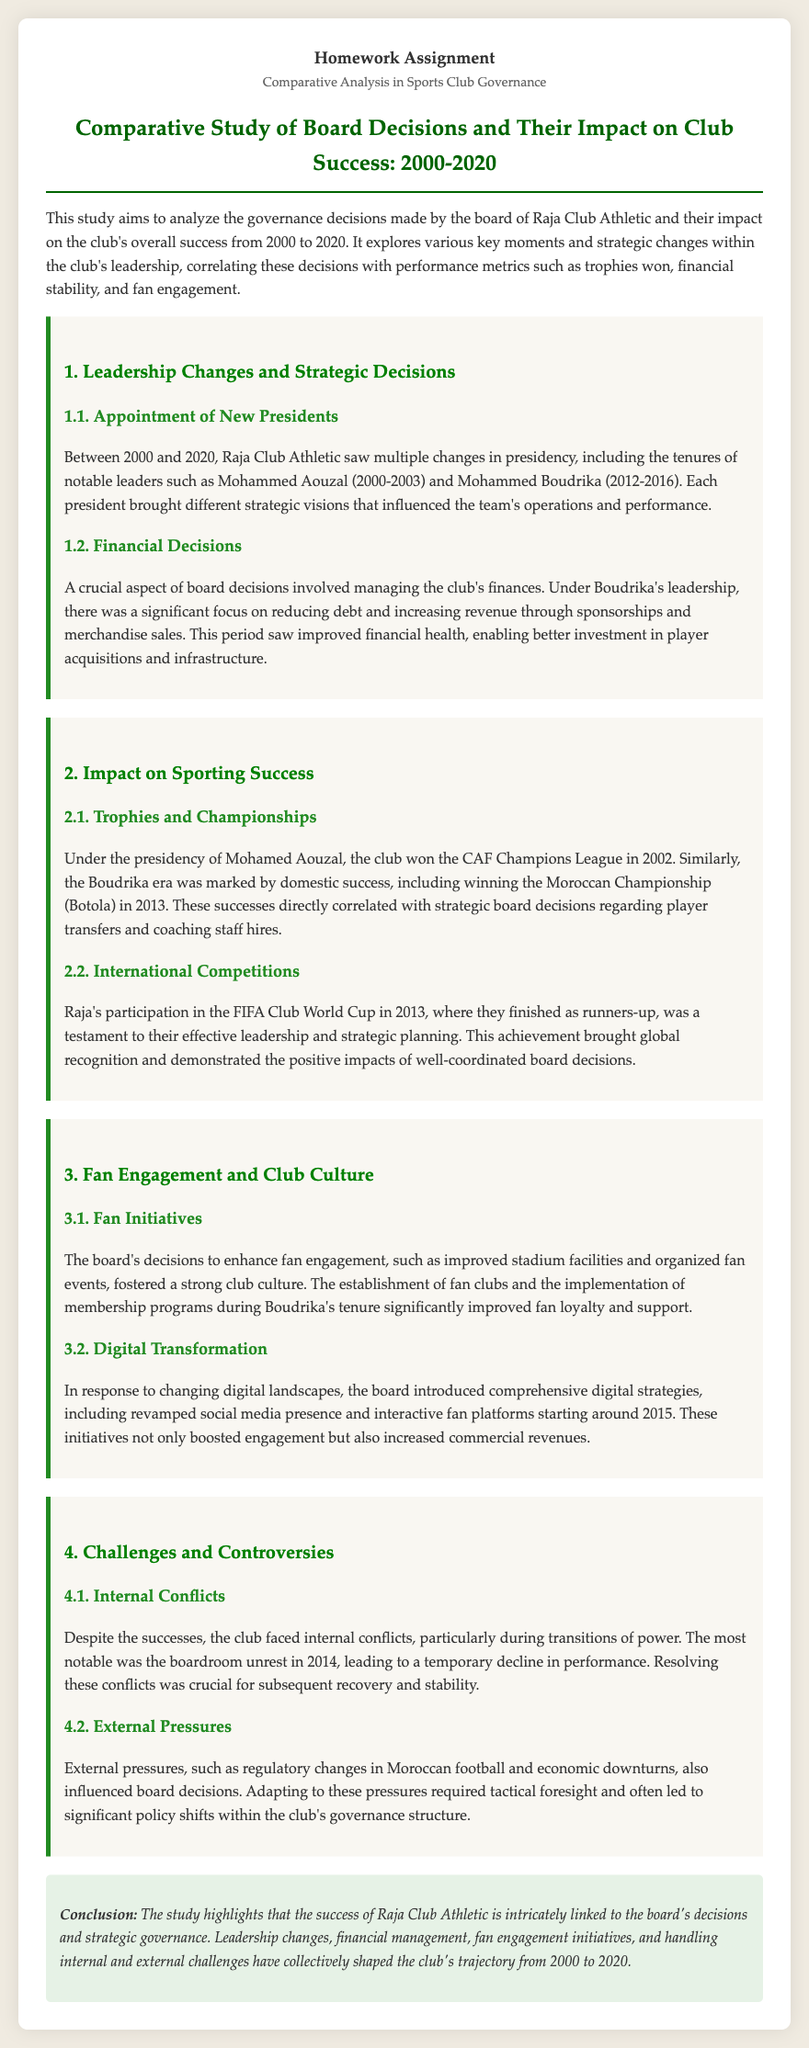What was the tenure of Mohammed Aouzal? The document states the tenure of Mohammed Aouzal was from 2000 to 2003.
Answer: 2000-2003 Which cup did Raja Club Athletic win in 2002? The document mentions that the club won the CAF Champions League in 2002 under Aouzal's presidency.
Answer: CAF Champions League What year did Raja Club Athletic achieve runners-up in the FIFA Club World Cup? The document indicates that Raja finished as runners-up in the FIFA Club World Cup in 2013.
Answer: 2013 Who was president during the 2013 Moroccan Championship victory? The document specifies that the Moroccan Championship (Botola) was won in 2013 during Boudrika's era.
Answer: Boudrika What type of decisions were emphasized during Boudrika’s leadership? The document suggests that Boudrika focused on reducing debt and increasing revenue through sponsorships and merchandise sales.
Answer: Financial Decisions Which year did boardroom unrest occur? The document notes that the most notable boardroom unrest happened in 2014.
Answer: 2014 What strategic initiative improved fan engagement during Boudrika’s tenure? The document highlights that establishing fan clubs and implementing membership programs improved fan engagement.
Answer: Fan clubs and membership programs What shift started around 2015 concerning digital strategies? The document states that the board introduced comprehensive digital strategies, including a revamped social media presence.
Answer: Revamped social media presence What is the main conclusion drawn from the study? The conclusion section elaborates that the club's success is linked to the board's decisions and governance strategies.
Answer: Board's decisions and governance strategies 